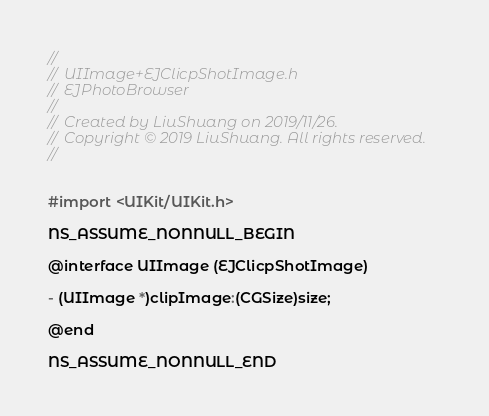Convert code to text. <code><loc_0><loc_0><loc_500><loc_500><_C_>//
//  UIImage+EJClicpShotImage.h
//  EJPhotoBrowser
//
//  Created by LiuShuang on 2019/11/26.
//  Copyright © 2019 LiuShuang. All rights reserved.
//


#import <UIKit/UIKit.h>

NS_ASSUME_NONNULL_BEGIN

@interface UIImage (EJClicpShotImage)

- (UIImage *)clipImage:(CGSize)size;

@end

NS_ASSUME_NONNULL_END
</code> 